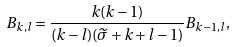Convert formula to latex. <formula><loc_0><loc_0><loc_500><loc_500>B _ { k , l } = \frac { k ( k - 1 ) } { ( k - l ) ( \widetilde { \sigma } + k + l - 1 ) } B _ { k - 1 , l } ,</formula> 